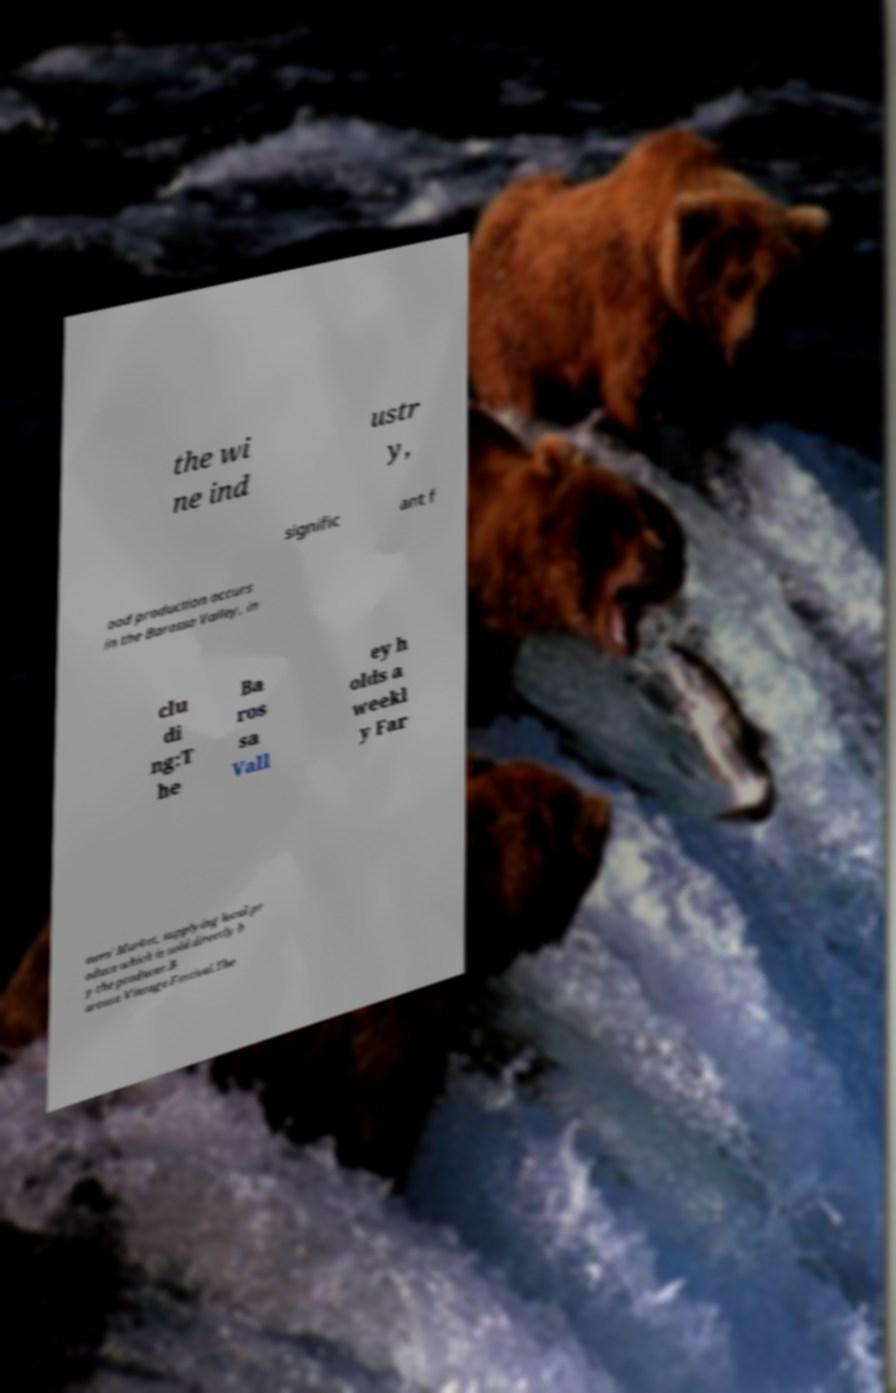Can you read and provide the text displayed in the image?This photo seems to have some interesting text. Can you extract and type it out for me? the wi ne ind ustr y, signific ant f ood production occurs in the Barossa Valley, in clu di ng:T he Ba ros sa Vall ey h olds a weekl y Far mers' Market, supplying local pr oduce which is sold directly b y the producer.B arossa Vintage Festival.The 